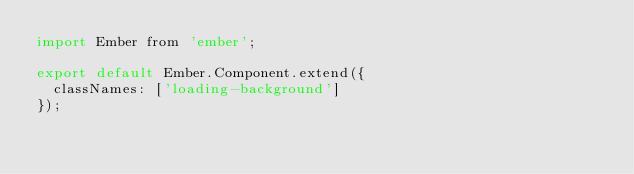Convert code to text. <code><loc_0><loc_0><loc_500><loc_500><_JavaScript_>import Ember from 'ember';

export default Ember.Component.extend({
  classNames: ['loading-background']
});
</code> 